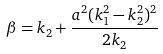Convert formula to latex. <formula><loc_0><loc_0><loc_500><loc_500>\beta = k _ { 2 } + \frac { a ^ { 2 } ( k _ { 1 } ^ { 2 } - k _ { 2 } ^ { 2 } ) ^ { 2 } } { 2 k _ { 2 } }</formula> 